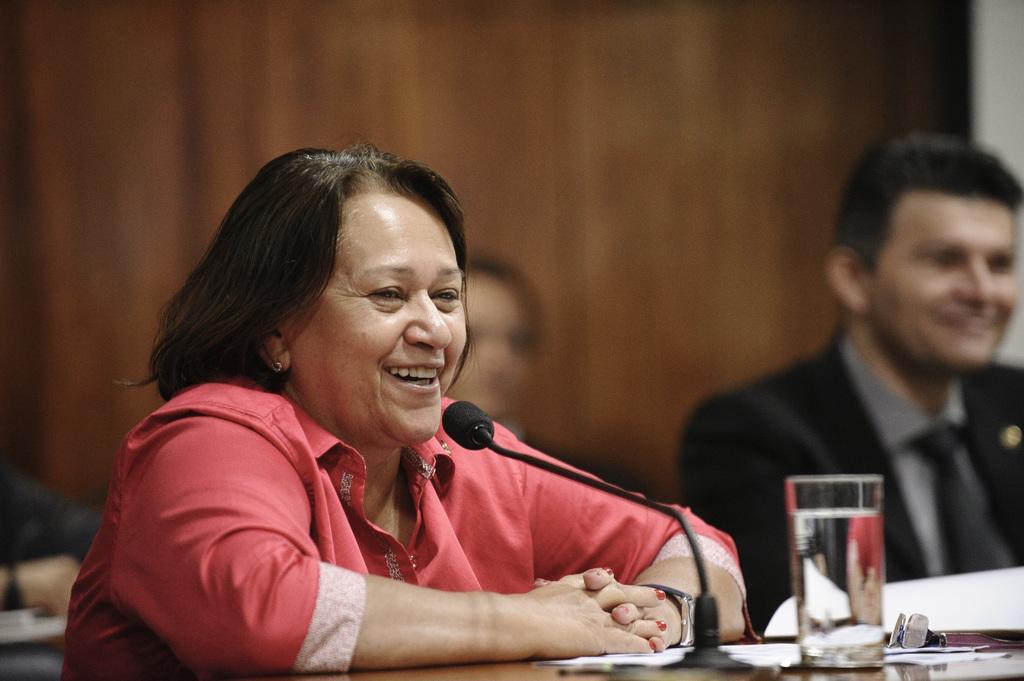Can you describe this image briefly? This picture is clicked inside. In the foreground there is a person wearing pink color shirt, sitting on the chair and smiling. On the right corner there is a table on the top of which a glass of water, spectacles, microphone and some papers are placed and there is a man wearing suit, smiling and sitting on the chair. In the background we can see the wall and a person seems to be sitting on the chair. 